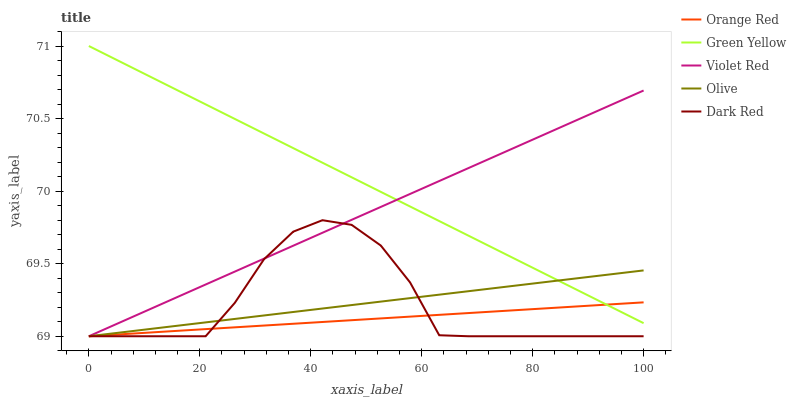Does Orange Red have the minimum area under the curve?
Answer yes or no. Yes. Does Green Yellow have the maximum area under the curve?
Answer yes or no. Yes. Does Dark Red have the minimum area under the curve?
Answer yes or no. No. Does Dark Red have the maximum area under the curve?
Answer yes or no. No. Is Orange Red the smoothest?
Answer yes or no. Yes. Is Dark Red the roughest?
Answer yes or no. Yes. Is Violet Red the smoothest?
Answer yes or no. No. Is Violet Red the roughest?
Answer yes or no. No. Does Olive have the lowest value?
Answer yes or no. Yes. Does Green Yellow have the lowest value?
Answer yes or no. No. Does Green Yellow have the highest value?
Answer yes or no. Yes. Does Dark Red have the highest value?
Answer yes or no. No. Is Dark Red less than Green Yellow?
Answer yes or no. Yes. Is Green Yellow greater than Dark Red?
Answer yes or no. Yes. Does Orange Red intersect Dark Red?
Answer yes or no. Yes. Is Orange Red less than Dark Red?
Answer yes or no. No. Is Orange Red greater than Dark Red?
Answer yes or no. No. Does Dark Red intersect Green Yellow?
Answer yes or no. No. 